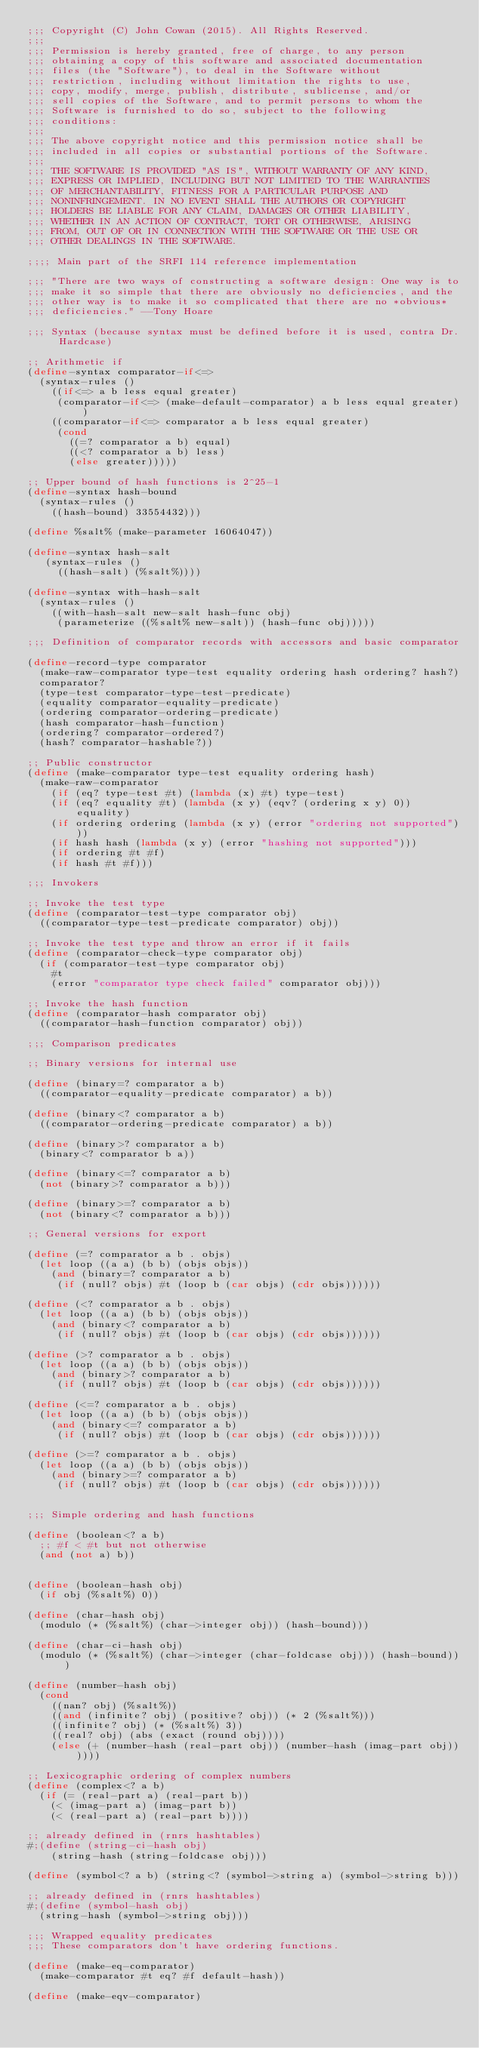Convert code to text. <code><loc_0><loc_0><loc_500><loc_500><_Scheme_>;;; Copyright (C) John Cowan (2015). All Rights Reserved.
;;; 
;;; Permission is hereby granted, free of charge, to any person
;;; obtaining a copy of this software and associated documentation
;;; files (the "Software"), to deal in the Software without
;;; restriction, including without limitation the rights to use,
;;; copy, modify, merge, publish, distribute, sublicense, and/or
;;; sell copies of the Software, and to permit persons to whom the
;;; Software is furnished to do so, subject to the following
;;; conditions:
;;; 
;;; The above copyright notice and this permission notice shall be
;;; included in all copies or substantial portions of the Software.
;;; 
;;; THE SOFTWARE IS PROVIDED "AS IS", WITHOUT WARRANTY OF ANY KIND,
;;; EXPRESS OR IMPLIED, INCLUDING BUT NOT LIMITED TO THE WARRANTIES
;;; OF MERCHANTABILITY, FITNESS FOR A PARTICULAR PURPOSE AND
;;; NONINFRINGEMENT. IN NO EVENT SHALL THE AUTHORS OR COPYRIGHT
;;; HOLDERS BE LIABLE FOR ANY CLAIM, DAMAGES OR OTHER LIABILITY,
;;; WHETHER IN AN ACTION OF CONTRACT, TORT OR OTHERWISE, ARISING
;;; FROM, OUT OF OR IN CONNECTION WITH THE SOFTWARE OR THE USE OR
;;; OTHER DEALINGS IN THE SOFTWARE. 

;;;; Main part of the SRFI 114 reference implementation

;;; "There are two ways of constructing a software design: One way is to
;;; make it so simple that there are obviously no deficiencies, and the
;;; other way is to make it so complicated that there are no *obvious*
;;; deficiencies." --Tony Hoare

;;; Syntax (because syntax must be defined before it is used, contra Dr. Hardcase)

;; Arithmetic if
(define-syntax comparator-if<=>
  (syntax-rules ()
    ((if<=> a b less equal greater)
     (comparator-if<=> (make-default-comparator) a b less equal greater))
    ((comparator-if<=> comparator a b less equal greater)
     (cond
       ((=? comparator a b) equal)
       ((<? comparator a b) less)
       (else greater)))))

;; Upper bound of hash functions is 2^25-1
(define-syntax hash-bound
  (syntax-rules ()
    ((hash-bound) 33554432)))

(define %salt% (make-parameter 16064047))

(define-syntax hash-salt
   (syntax-rules ()
     ((hash-salt) (%salt%))))

(define-syntax with-hash-salt
  (syntax-rules ()
    ((with-hash-salt new-salt hash-func obj)
     (parameterize ((%salt% new-salt)) (hash-func obj)))))

;;; Definition of comparator records with accessors and basic comparator

(define-record-type comparator
  (make-raw-comparator type-test equality ordering hash ordering? hash?)
  comparator?
  (type-test comparator-type-test-predicate)
  (equality comparator-equality-predicate)
  (ordering comparator-ordering-predicate)
  (hash comparator-hash-function)
  (ordering? comparator-ordered?)
  (hash? comparator-hashable?))

;; Public constructor
(define (make-comparator type-test equality ordering hash)
  (make-raw-comparator
    (if (eq? type-test #t) (lambda (x) #t) type-test)
    (if (eq? equality #t) (lambda (x y) (eqv? (ordering x y) 0)) equality)
    (if ordering ordering (lambda (x y) (error "ordering not supported")))
    (if hash hash (lambda (x y) (error "hashing not supported")))
    (if ordering #t #f)
    (if hash #t #f)))

;;; Invokers

;; Invoke the test type
(define (comparator-test-type comparator obj)
  ((comparator-type-test-predicate comparator) obj))

;; Invoke the test type and throw an error if it fails
(define (comparator-check-type comparator obj)
  (if (comparator-test-type comparator obj)
    #t
    (error "comparator type check failed" comparator obj)))

;; Invoke the hash function
(define (comparator-hash comparator obj)
  ((comparator-hash-function comparator) obj))

;;; Comparison predicates

;; Binary versions for internal use

(define (binary=? comparator a b)
  ((comparator-equality-predicate comparator) a b))

(define (binary<? comparator a b)
  ((comparator-ordering-predicate comparator) a b))

(define (binary>? comparator a b)
  (binary<? comparator b a))

(define (binary<=? comparator a b)
  (not (binary>? comparator a b)))

(define (binary>=? comparator a b)
  (not (binary<? comparator a b)))

;; General versions for export

(define (=? comparator a b . objs)
  (let loop ((a a) (b b) (objs objs))
    (and (binary=? comparator a b)
	 (if (null? objs) #t (loop b (car objs) (cdr objs))))))

(define (<? comparator a b . objs)
  (let loop ((a a) (b b) (objs objs))
    (and (binary<? comparator a b)
	 (if (null? objs) #t (loop b (car objs) (cdr objs))))))

(define (>? comparator a b . objs)
  (let loop ((a a) (b b) (objs objs))
    (and (binary>? comparator a b)
	 (if (null? objs) #t (loop b (car objs) (cdr objs))))))

(define (<=? comparator a b . objs)
  (let loop ((a a) (b b) (objs objs))
    (and (binary<=? comparator a b)
	 (if (null? objs) #t (loop b (car objs) (cdr objs))))))

(define (>=? comparator a b . objs)
  (let loop ((a a) (b b) (objs objs))
    (and (binary>=? comparator a b)
	 (if (null? objs) #t (loop b (car objs) (cdr objs))))))


;;; Simple ordering and hash functions

(define (boolean<? a b)
  ;; #f < #t but not otherwise
  (and (not a) b))


(define (boolean-hash obj)
  (if obj (%salt%) 0))

(define (char-hash obj)
  (modulo (* (%salt%) (char->integer obj)) (hash-bound)))

(define (char-ci-hash obj)
  (modulo (* (%salt%) (char->integer (char-foldcase obj))) (hash-bound)))

(define (number-hash obj)
  (cond
    ((nan? obj) (%salt%))
    ((and (infinite? obj) (positive? obj)) (* 2 (%salt%)))
    ((infinite? obj) (* (%salt%) 3))
    ((real? obj) (abs (exact (round obj))))
    (else (+ (number-hash (real-part obj)) (number-hash (imag-part obj))))))

;; Lexicographic ordering of complex numbers
(define (complex<? a b)
  (if (= (real-part a) (real-part b))
    (< (imag-part a) (imag-part b))
    (< (real-part a) (real-part b))))

;; already defined in (rnrs hashtables)
#;(define (string-ci-hash obj)
    (string-hash (string-foldcase obj)))

(define (symbol<? a b) (string<? (symbol->string a) (symbol->string b)))

;; already defined in (rnrs hashtables)
#;(define (symbol-hash obj)
  (string-hash (symbol->string obj)))

;;; Wrapped equality predicates
;;; These comparators don't have ordering functions.

(define (make-eq-comparator)
  (make-comparator #t eq? #f default-hash))

(define (make-eqv-comparator)</code> 